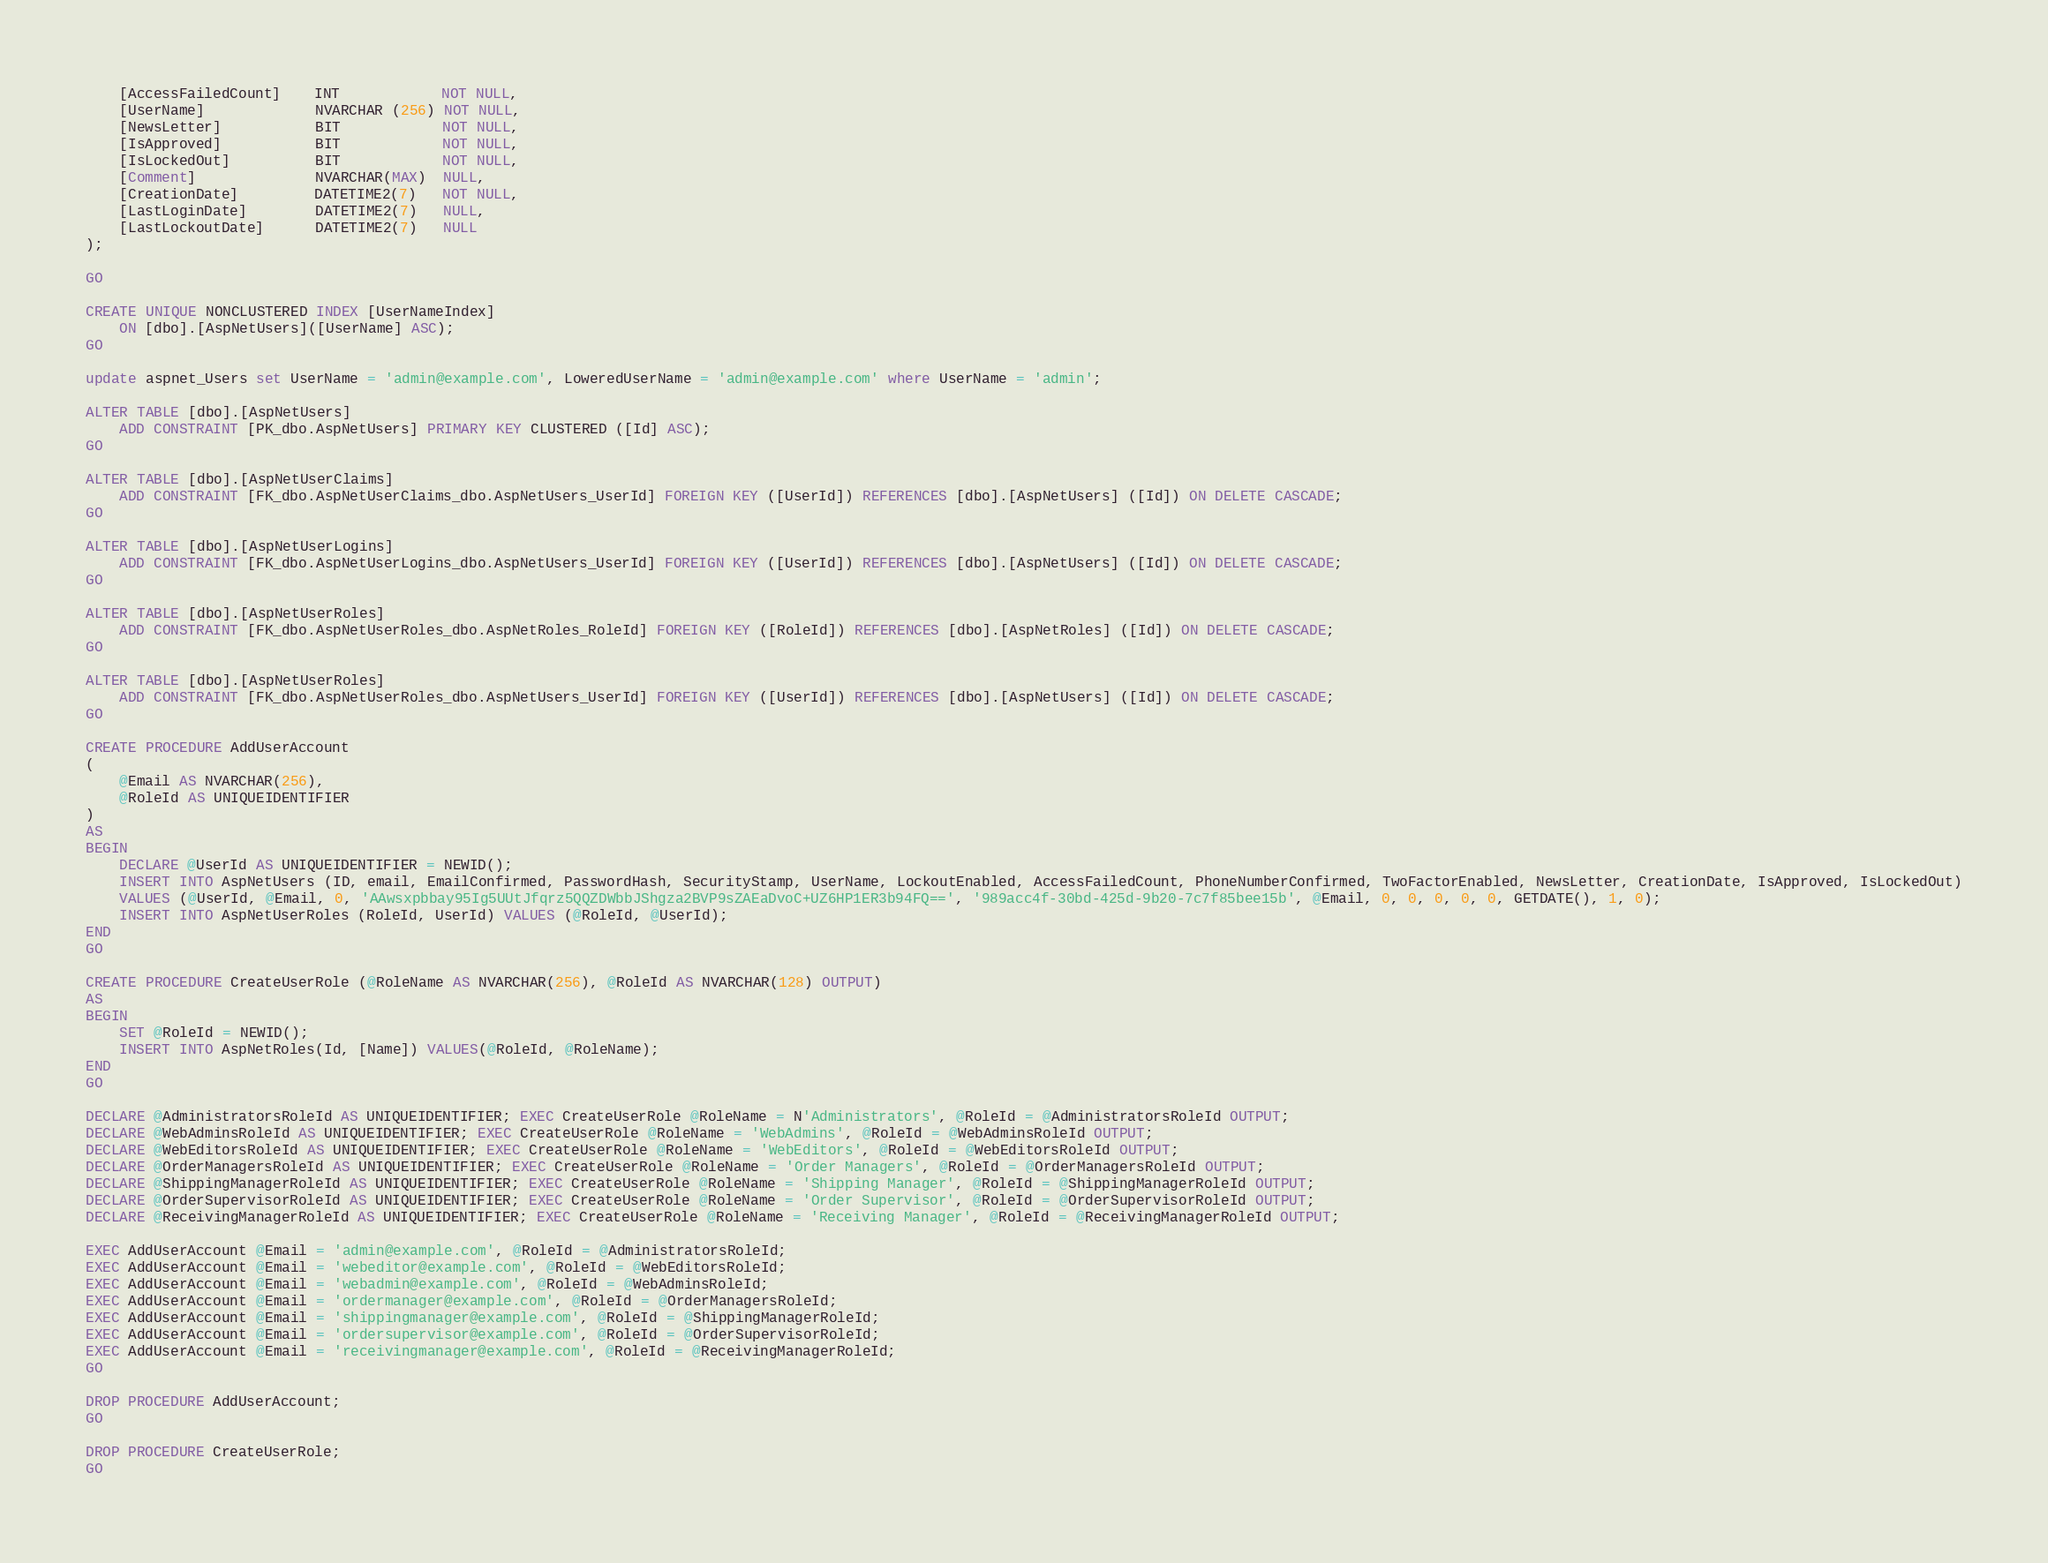Convert code to text. <code><loc_0><loc_0><loc_500><loc_500><_SQL_>    [AccessFailedCount]    INT            NOT NULL,
    [UserName]             NVARCHAR (256) NOT NULL,
	[NewsLetter]           BIT            NOT NULL,
	[IsApproved]	       BIT            NOT NULL,
	[IsLockedOut]          BIT            NOT NULL,
	[Comment]              NVARCHAR(MAX)  NULL,
	[CreationDate]         DATETIME2(7)   NOT NULL,
	[LastLoginDate]        DATETIME2(7)   NULL,
	[LastLockoutDate]      DATETIME2(7)   NULL
);

GO

CREATE UNIQUE NONCLUSTERED INDEX [UserNameIndex]
    ON [dbo].[AspNetUsers]([UserName] ASC);
GO

update aspnet_Users set UserName = 'admin@example.com', LoweredUserName = 'admin@example.com' where UserName = 'admin';

ALTER TABLE [dbo].[AspNetUsers]
    ADD CONSTRAINT [PK_dbo.AspNetUsers] PRIMARY KEY CLUSTERED ([Id] ASC);
GO

ALTER TABLE [dbo].[AspNetUserClaims]
    ADD CONSTRAINT [FK_dbo.AspNetUserClaims_dbo.AspNetUsers_UserId] FOREIGN KEY ([UserId]) REFERENCES [dbo].[AspNetUsers] ([Id]) ON DELETE CASCADE;
GO

ALTER TABLE [dbo].[AspNetUserLogins]
    ADD CONSTRAINT [FK_dbo.AspNetUserLogins_dbo.AspNetUsers_UserId] FOREIGN KEY ([UserId]) REFERENCES [dbo].[AspNetUsers] ([Id]) ON DELETE CASCADE;
GO

ALTER TABLE [dbo].[AspNetUserRoles]
    ADD CONSTRAINT [FK_dbo.AspNetUserRoles_dbo.AspNetRoles_RoleId] FOREIGN KEY ([RoleId]) REFERENCES [dbo].[AspNetRoles] ([Id]) ON DELETE CASCADE;
GO

ALTER TABLE [dbo].[AspNetUserRoles]
    ADD CONSTRAINT [FK_dbo.AspNetUserRoles_dbo.AspNetUsers_UserId] FOREIGN KEY ([UserId]) REFERENCES [dbo].[AspNetUsers] ([Id]) ON DELETE CASCADE;
GO

CREATE PROCEDURE AddUserAccount
(
	@Email AS NVARCHAR(256),
	@RoleId AS UNIQUEIDENTIFIER
)
AS
BEGIN
	DECLARE @UserId AS UNIQUEIDENTIFIER = NEWID();
	INSERT INTO AspNetUsers (ID, email, EmailConfirmed, PasswordHash, SecurityStamp, UserName, LockoutEnabled, AccessFailedCount, PhoneNumberConfirmed, TwoFactorEnabled, NewsLetter, CreationDate, IsApproved, IsLockedOut)
	VALUES (@UserId, @Email, 0, 'AAwsxpbbay95Ig5UUtJfqrz5QQZDWbbJShgza2BVP9sZAEaDvoC+UZ6HP1ER3b94FQ==', '989acc4f-30bd-425d-9b20-7c7f85bee15b', @Email, 0, 0, 0, 0, 0, GETDATE(), 1, 0);
	INSERT INTO AspNetUserRoles (RoleId, UserId) VALUES (@RoleId, @UserId);
END
GO

CREATE PROCEDURE CreateUserRole (@RoleName AS NVARCHAR(256), @RoleId AS NVARCHAR(128) OUTPUT)
AS
BEGIN
    SET @RoleId = NEWID();
    INSERT INTO AspNetRoles(Id, [Name]) VALUES(@RoleId, @RoleName);
END
GO

DECLARE @AdministratorsRoleId AS UNIQUEIDENTIFIER; EXEC CreateUserRole @RoleName = N'Administrators', @RoleId = @AdministratorsRoleId OUTPUT;
DECLARE @WebAdminsRoleId AS UNIQUEIDENTIFIER; EXEC CreateUserRole @RoleName = 'WebAdmins', @RoleId = @WebAdminsRoleId OUTPUT;
DECLARE @WebEditorsRoleId AS UNIQUEIDENTIFIER; EXEC CreateUserRole @RoleName = 'WebEditors', @RoleId = @WebEditorsRoleId OUTPUT;
DECLARE @OrderManagersRoleId AS UNIQUEIDENTIFIER; EXEC CreateUserRole @RoleName = 'Order Managers', @RoleId = @OrderManagersRoleId OUTPUT;
DECLARE @ShippingManagerRoleId AS UNIQUEIDENTIFIER; EXEC CreateUserRole @RoleName = 'Shipping Manager', @RoleId = @ShippingManagerRoleId OUTPUT;
DECLARE @OrderSupervisorRoleId AS UNIQUEIDENTIFIER; EXEC CreateUserRole @RoleName = 'Order Supervisor', @RoleId = @OrderSupervisorRoleId OUTPUT;
DECLARE @ReceivingManagerRoleId AS UNIQUEIDENTIFIER; EXEC CreateUserRole @RoleName = 'Receiving Manager', @RoleId = @ReceivingManagerRoleId OUTPUT;

EXEC AddUserAccount @Email = 'admin@example.com', @RoleId = @AdministratorsRoleId;
EXEC AddUserAccount @Email = 'webeditor@example.com', @RoleId = @WebEditorsRoleId;
EXEC AddUserAccount @Email = 'webadmin@example.com', @RoleId = @WebAdminsRoleId;
EXEC AddUserAccount @Email = 'ordermanager@example.com', @RoleId = @OrderManagersRoleId;
EXEC AddUserAccount @Email = 'shippingmanager@example.com', @RoleId = @ShippingManagerRoleId;
EXEC AddUserAccount @Email = 'ordersupervisor@example.com', @RoleId = @OrderSupervisorRoleId;
EXEC AddUserAccount @Email = 'receivingmanager@example.com', @RoleId = @ReceivingManagerRoleId;
GO

DROP PROCEDURE AddUserAccount;
GO

DROP PROCEDURE CreateUserRole;
GO</code> 